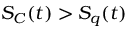Convert formula to latex. <formula><loc_0><loc_0><loc_500><loc_500>S _ { C } ( t ) > S _ { q } ( t )</formula> 